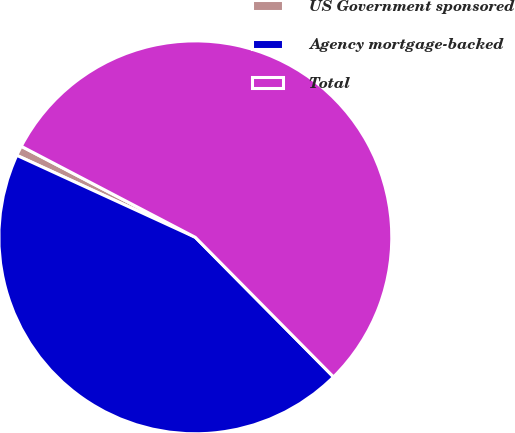<chart> <loc_0><loc_0><loc_500><loc_500><pie_chart><fcel>US Government sponsored<fcel>Agency mortgage-backed<fcel>Total<nl><fcel>0.82%<fcel>44.27%<fcel>54.91%<nl></chart> 